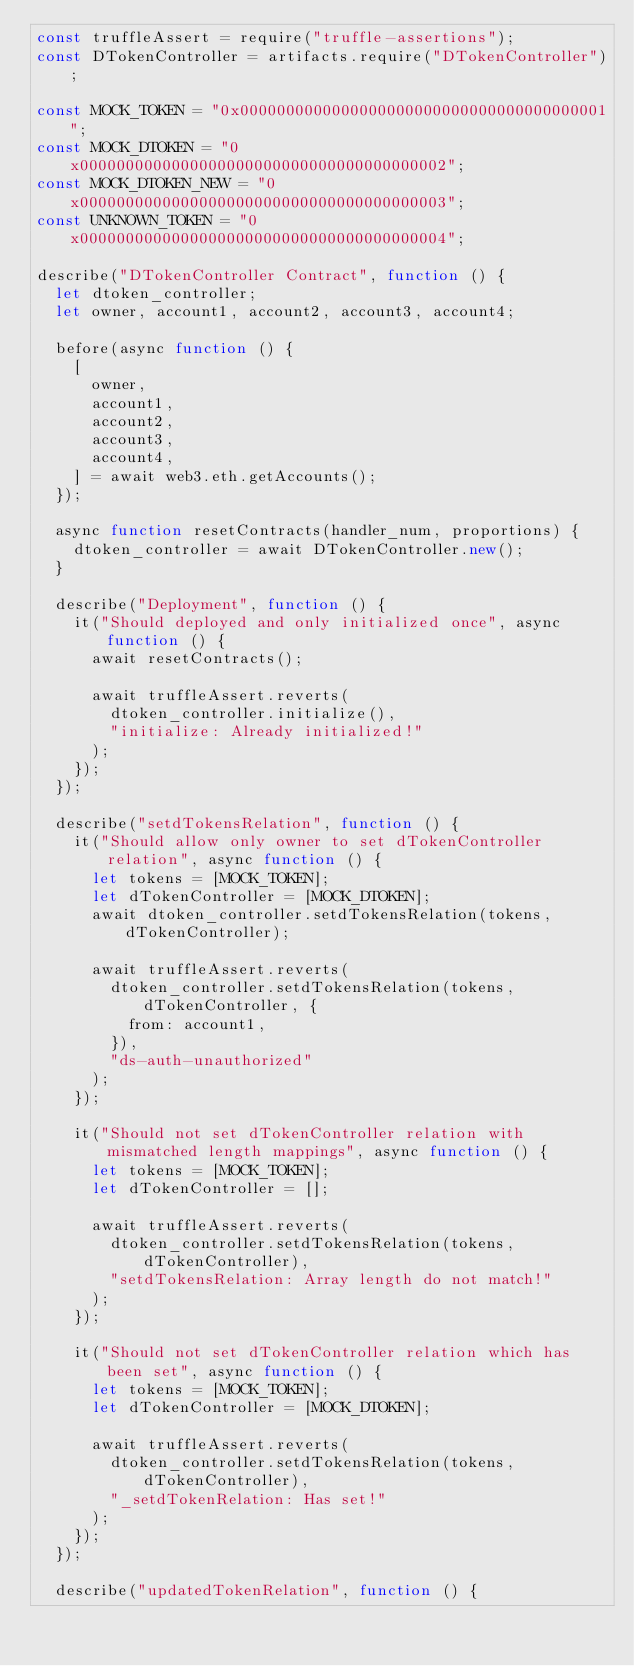Convert code to text. <code><loc_0><loc_0><loc_500><loc_500><_JavaScript_>const truffleAssert = require("truffle-assertions");
const DTokenController = artifacts.require("DTokenController");

const MOCK_TOKEN = "0x0000000000000000000000000000000000000001";
const MOCK_DTOKEN = "0x0000000000000000000000000000000000000002";
const MOCK_DTOKEN_NEW = "0x0000000000000000000000000000000000000003";
const UNKNOWN_TOKEN = "0x0000000000000000000000000000000000000004";

describe("DTokenController Contract", function () {
  let dtoken_controller;
  let owner, account1, account2, account3, account4;

  before(async function () {
    [
      owner,
      account1,
      account2,
      account3,
      account4,
    ] = await web3.eth.getAccounts();
  });

  async function resetContracts(handler_num, proportions) {
    dtoken_controller = await DTokenController.new();
  }

  describe("Deployment", function () {
    it("Should deployed and only initialized once", async function () {
      await resetContracts();

      await truffleAssert.reverts(
        dtoken_controller.initialize(),
        "initialize: Already initialized!"
      );
    });
  });

  describe("setdTokensRelation", function () {
    it("Should allow only owner to set dTokenController relation", async function () {
      let tokens = [MOCK_TOKEN];
      let dTokenController = [MOCK_DTOKEN];
      await dtoken_controller.setdTokensRelation(tokens, dTokenController);

      await truffleAssert.reverts(
        dtoken_controller.setdTokensRelation(tokens, dTokenController, {
          from: account1,
        }),
        "ds-auth-unauthorized"
      );
    });

    it("Should not set dTokenController relation with mismatched length mappings", async function () {
      let tokens = [MOCK_TOKEN];
      let dTokenController = [];

      await truffleAssert.reverts(
        dtoken_controller.setdTokensRelation(tokens, dTokenController),
        "setdTokensRelation: Array length do not match!"
      );
    });

    it("Should not set dTokenController relation which has been set", async function () {
      let tokens = [MOCK_TOKEN];
      let dTokenController = [MOCK_DTOKEN];

      await truffleAssert.reverts(
        dtoken_controller.setdTokensRelation(tokens, dTokenController),
        "_setdTokenRelation: Has set!"
      );
    });
  });

  describe("updatedTokenRelation", function () {</code> 